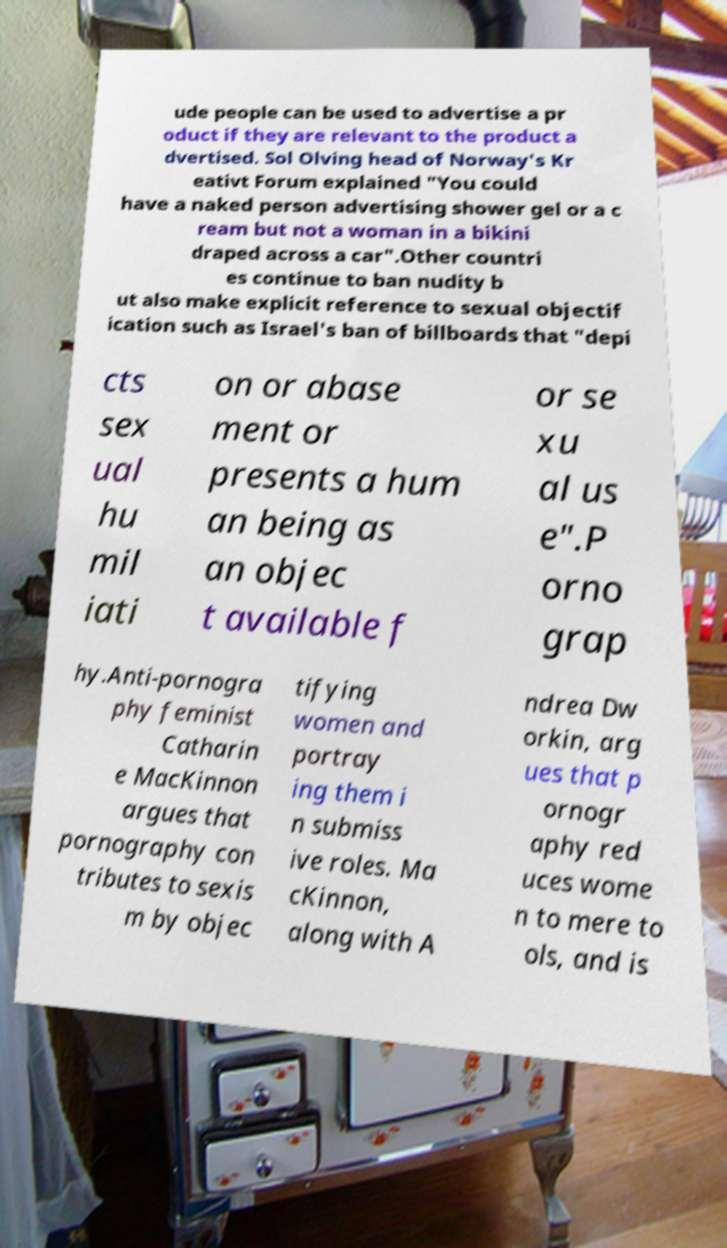Can you accurately transcribe the text from the provided image for me? ude people can be used to advertise a pr oduct if they are relevant to the product a dvertised. Sol Olving head of Norway's Kr eativt Forum explained "You could have a naked person advertising shower gel or a c ream but not a woman in a bikini draped across a car".Other countri es continue to ban nudity b ut also make explicit reference to sexual objectif ication such as Israel's ban of billboards that "depi cts sex ual hu mil iati on or abase ment or presents a hum an being as an objec t available f or se xu al us e".P orno grap hy.Anti-pornogra phy feminist Catharin e MacKinnon argues that pornography con tributes to sexis m by objec tifying women and portray ing them i n submiss ive roles. Ma cKinnon, along with A ndrea Dw orkin, arg ues that p ornogr aphy red uces wome n to mere to ols, and is 